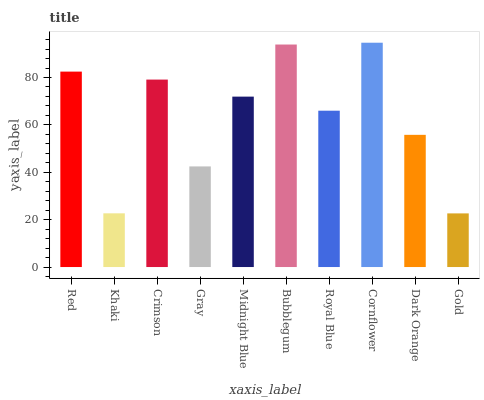Is Gold the minimum?
Answer yes or no. Yes. Is Cornflower the maximum?
Answer yes or no. Yes. Is Khaki the minimum?
Answer yes or no. No. Is Khaki the maximum?
Answer yes or no. No. Is Red greater than Khaki?
Answer yes or no. Yes. Is Khaki less than Red?
Answer yes or no. Yes. Is Khaki greater than Red?
Answer yes or no. No. Is Red less than Khaki?
Answer yes or no. No. Is Midnight Blue the high median?
Answer yes or no. Yes. Is Royal Blue the low median?
Answer yes or no. Yes. Is Bubblegum the high median?
Answer yes or no. No. Is Red the low median?
Answer yes or no. No. 